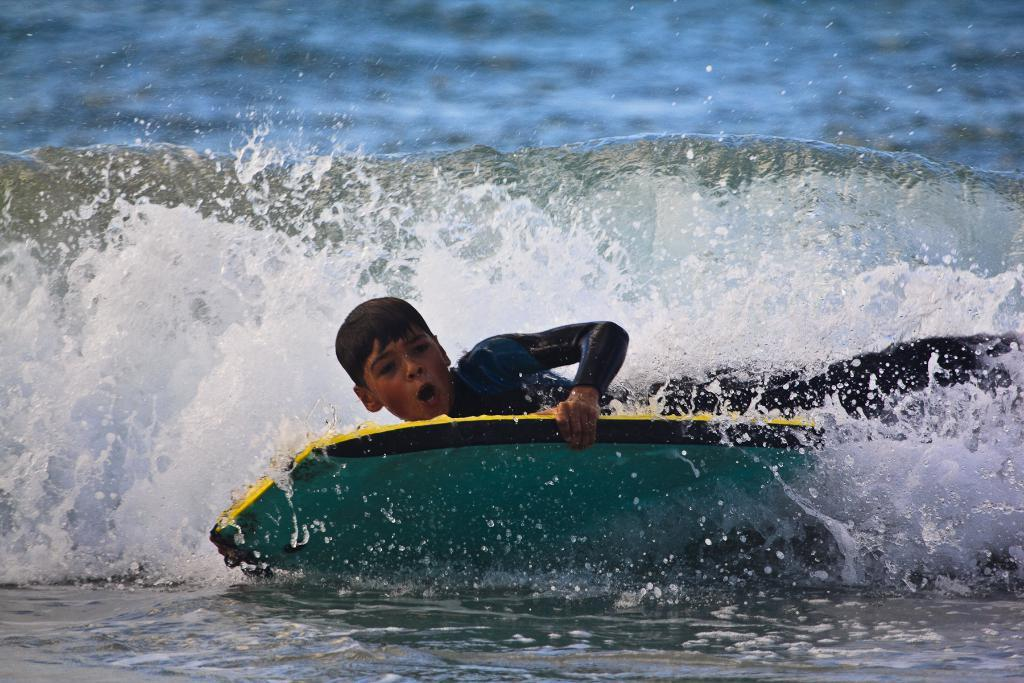What is the main subject of the image? The main subject of the image is a man. What is the man doing in the image? The man is surfing on a skateboard in the image. Where is the skateboard located in the image? The skateboard is on the water in the image. What type of plant can be seen growing in the frame of the image? There is no plant visible in the image, as it features a man surfing on a skateboard on the water. 